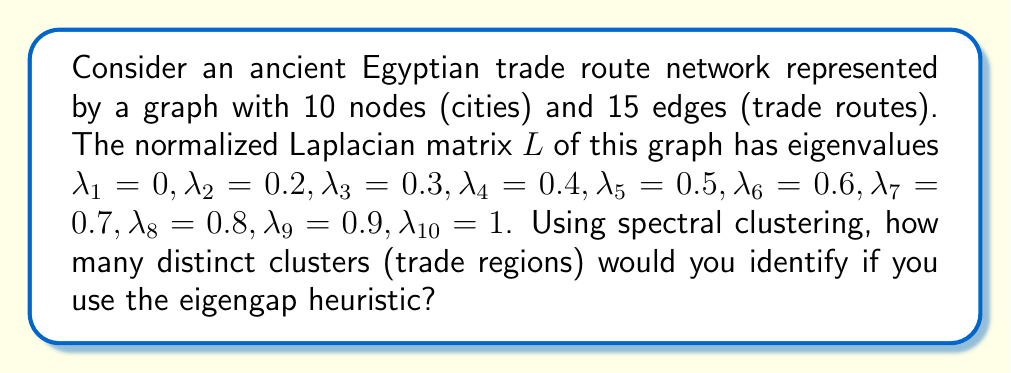Show me your answer to this math problem. To solve this problem using spectral clustering and the eigengap heuristic, we follow these steps:

1) Recall that the eigengap heuristic suggests choosing the number of clusters $k$ such that the gap $\delta_k = |\lambda_{k+1} - \lambda_k|$ is largest.

2) Calculate the gaps between consecutive eigenvalues:
   $\delta_1 = |\lambda_2 - \lambda_1| = |0.2 - 0| = 0.2$
   $\delta_2 = |\lambda_3 - \lambda_2| = |0.3 - 0.2| = 0.1$
   $\delta_3 = |\lambda_4 - \lambda_3| = |0.4 - 0.3| = 0.1$
   $\delta_4 = |\lambda_5 - \lambda_4| = |0.5 - 0.4| = 0.1$
   $\delta_5 = |\lambda_6 - \lambda_5| = |0.6 - 0.5| = 0.1$
   $\delta_6 = |\lambda_7 - \lambda_6| = |0.7 - 0.6| = 0.1$
   $\delta_7 = |\lambda_8 - \lambda_7| = |0.8 - 0.7| = 0.1$
   $\delta_8 = |\lambda_9 - \lambda_8| = |0.9 - 0.8| = 0.1$
   $\delta_9 = |\lambda_{10} - \lambda_9| = |1 - 0.9| = 0.1$

3) Identify the largest gap:
   The largest gap is $\delta_1 = 0.2$

4) The number of clusters is determined by the index of the largest gap:
   Since the largest gap is $\delta_1$, we choose $k = 1$

5) However, in spectral clustering, we always have at least 2 clusters (unless the graph is fully connected, which is not the case here as $\lambda_{10} \neq 0$).

Therefore, we identify 2 distinct clusters (trade regions) in this ancient Egyptian trade route network.
Answer: 2 clusters 